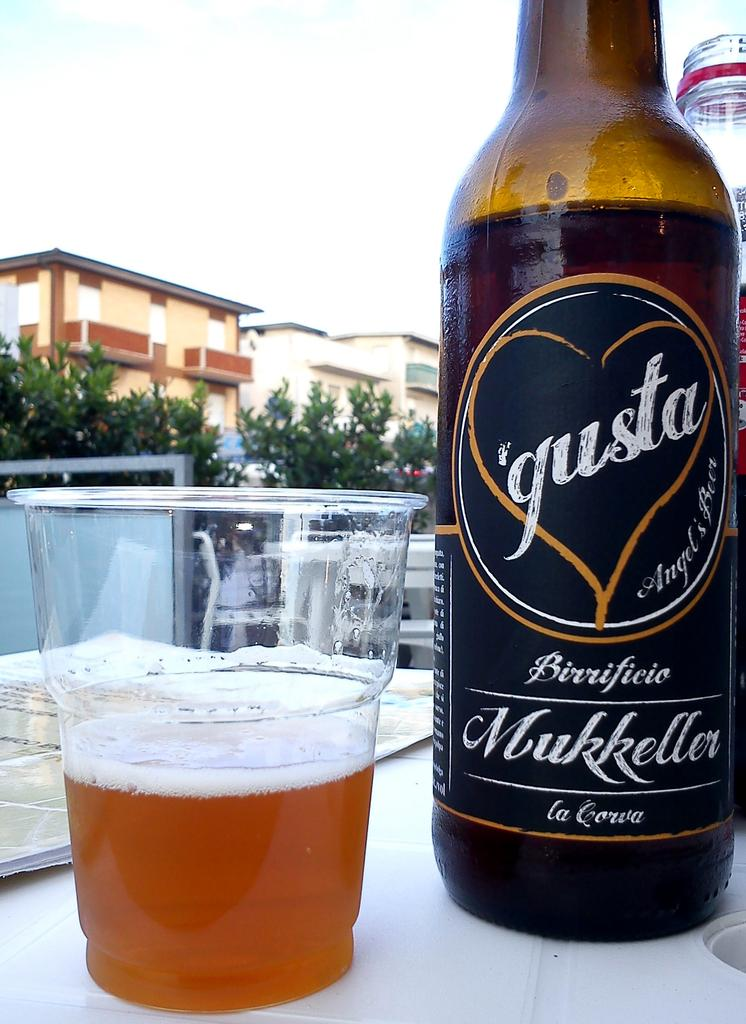<image>
Summarize the visual content of the image. A plastic cup filled with beer is placed side by side with a bottle of 'gusta beer. 